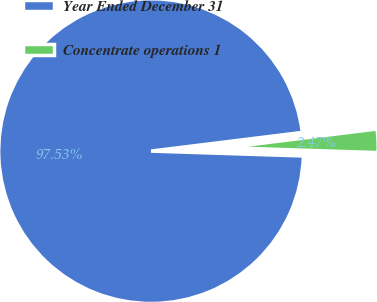<chart> <loc_0><loc_0><loc_500><loc_500><pie_chart><fcel>Year Ended December 31<fcel>Concentrate operations 1<nl><fcel>97.53%<fcel>2.47%<nl></chart> 